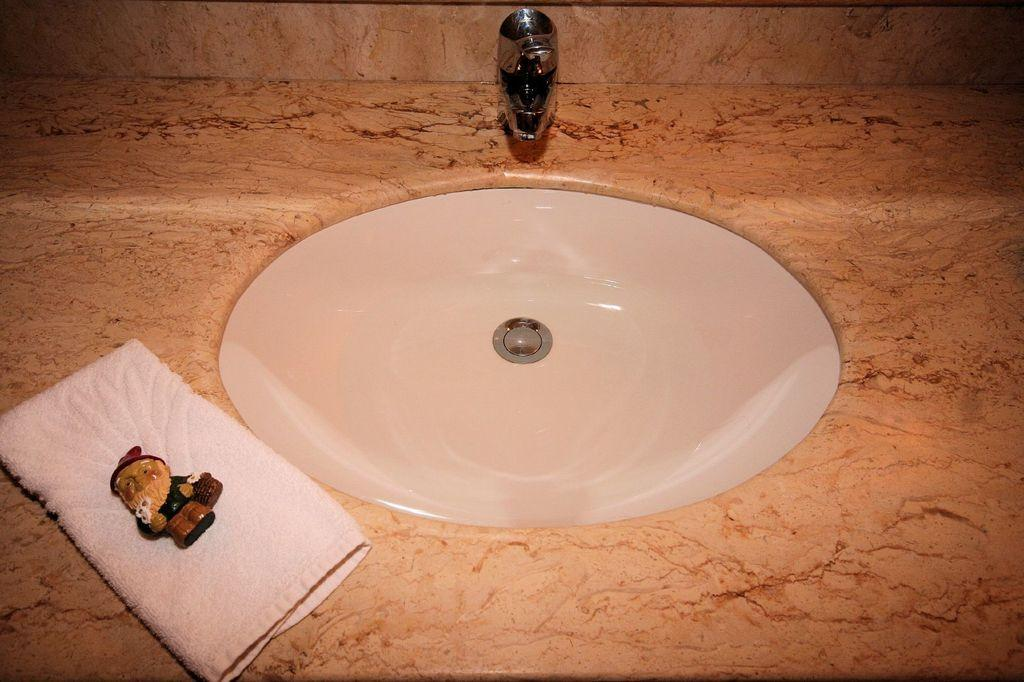What is the main object in the image? There is a wash basin in the image. What is attached to the wash basin? There is a tap in the image. What item might be used for cleaning or drying in the image? There is a napkin in the image. What type of object is present that is typically used for play? There is a toy in the image. What type of list can be seen hanging on the wall in the image? There is no list present in the image; it only contains a wash basin, a tap, a napkin, and a toy. 